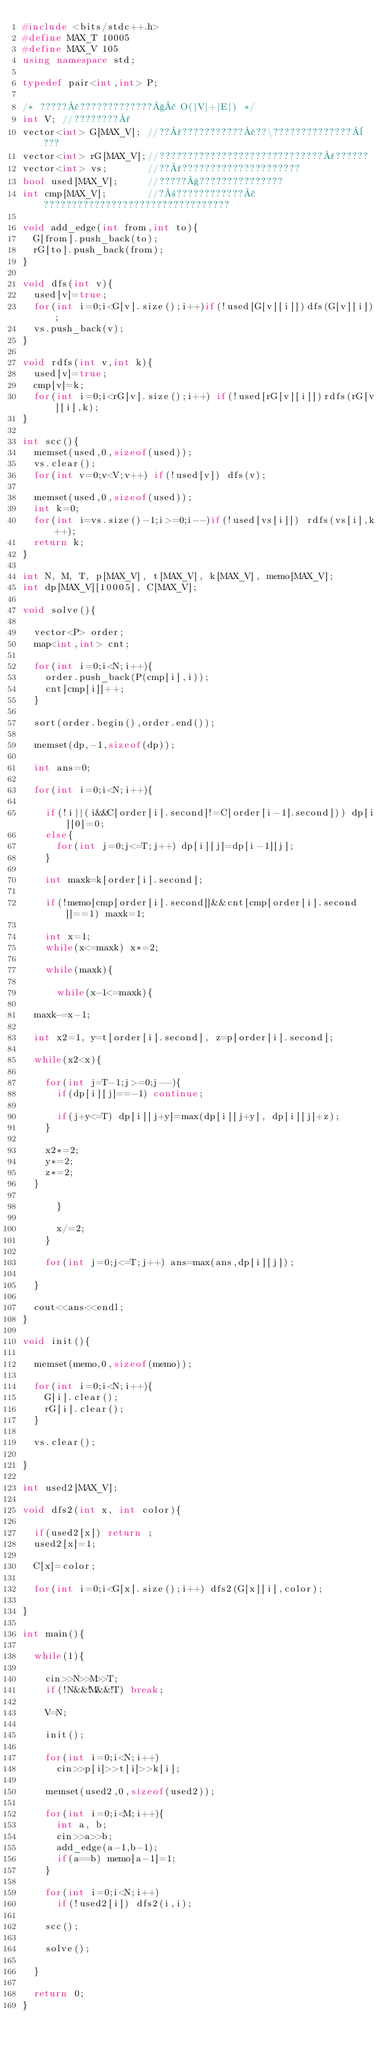Convert code to text. <code><loc_0><loc_0><loc_500><loc_500><_C++_>#include <bits/stdc++.h>
#define MAX_T 10005
#define MAX_V 105
using namespace std;

typedef pair<int,int> P;

/* ?????£?????????????§£ O(|V|+|E|) */
int V; //????????°
vector<int> G[MAX_V]; //??°???????????£??\??????????????¨???
vector<int> rG[MAX_V];//?????????????????????????????°??????
vector<int> vs;       //??°?????????????????????
bool used[MAX_V];     //?????§???????????????
int cmp[MAX_V];       //?±????????????£?????????????????????????????????

void add_edge(int from,int to){
  G[from].push_back(to);
  rG[to].push_back(from);
}

void dfs(int v){
  used[v]=true;
  for(int i=0;i<G[v].size();i++)if(!used[G[v][i]])dfs(G[v][i]);
  vs.push_back(v);
}

void rdfs(int v,int k){
  used[v]=true;
  cmp[v]=k;
  for(int i=0;i<rG[v].size();i++) if(!used[rG[v][i]])rdfs(rG[v][i],k);
}

int scc(){
  memset(used,0,sizeof(used));
  vs.clear();
  for(int v=0;v<V;v++) if(!used[v]) dfs(v);
  
  memset(used,0,sizeof(used));
  int k=0;
  for(int i=vs.size()-1;i>=0;i--)if(!used[vs[i]]) rdfs(vs[i],k++);
  return k;
}

int N, M, T, p[MAX_V], t[MAX_V], k[MAX_V], memo[MAX_V];
int dp[MAX_V][10005], C[MAX_V];

void solve(){
  
  vector<P> order;
  map<int,int> cnt;
  
  for(int i=0;i<N;i++){
    order.push_back(P(cmp[i],i));
    cnt[cmp[i]]++;
  }
  
  sort(order.begin(),order.end());
  
  memset(dp,-1,sizeof(dp));
  
  int ans=0;
    
  for(int i=0;i<N;i++){
    
    if(!i||(i&&C[order[i].second]!=C[order[i-1].second])) dp[i][0]=0;
    else{
      for(int j=0;j<=T;j++) dp[i][j]=dp[i-1][j];
    }
    
    int maxk=k[order[i].second];
    
    if(!memo[cmp[order[i].second]]&&cnt[cmp[order[i].second]]==1) maxk=1;
    
    int x=1;
    while(x<=maxk) x*=2;
    
    while(maxk){
      
      while(x-1<=maxk){
	
	maxk-=x-1;
	
	int x2=1, y=t[order[i].second], z=p[order[i].second];
	
	while(x2<x){
	  
	  for(int j=T-1;j>=0;j--){
	    if(dp[i][j]==-1) continue;
	    
	    if(j+y<=T) dp[i][j+y]=max(dp[i][j+y], dp[i][j]+z);
	  }
	  
	  x2*=2;
	  y*=2;
	  z*=2;
	}
	
      }
      
      x/=2;
    }
    
    for(int j=0;j<=T;j++) ans=max(ans,dp[i][j]);
    
  }
  
  cout<<ans<<endl;
}

void init(){
  
  memset(memo,0,sizeof(memo));
  
  for(int i=0;i<N;i++){
    G[i].clear();
    rG[i].clear();
  }
  
  vs.clear();
  
}

int used2[MAX_V];

void dfs2(int x, int color){
  
  if(used2[x]) return ;
  used2[x]=1;
  
  C[x]=color;
  
  for(int i=0;i<G[x].size();i++) dfs2(G[x][i],color);
  
}

int main(){

  while(1){
  
    cin>>N>>M>>T;
    if(!N&&!M&&!T) break;
    
    V=N;
  
    init();
  
    for(int i=0;i<N;i++)
      cin>>p[i]>>t[i]>>k[i];
    
    memset(used2,0,sizeof(used2));
    
    for(int i=0;i<M;i++){
      int a, b;
      cin>>a>>b;
      add_edge(a-1,b-1);
      if(a==b) memo[a-1]=1;
    }
    
    for(int i=0;i<N;i++)
      if(!used2[i]) dfs2(i,i);
    
    scc();
    
    solve();
    
  }
  
  return 0;
}</code> 